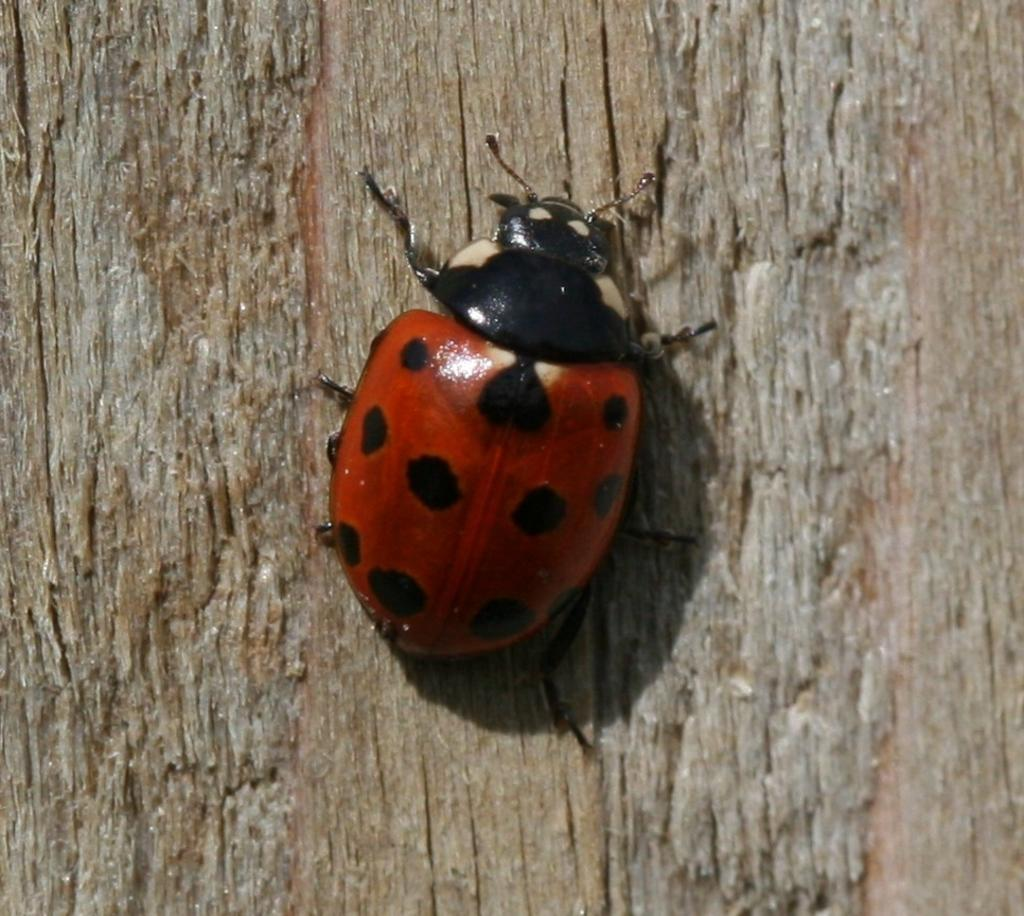What is the main subject in the center of the image? There is an insect in the center of the image. What can be seen in the background of the image? There is a tree in the background of the image. What type of fang does the grandfather have in the image? There is no grandfather or fang present in the image; it features an insect and a tree. 